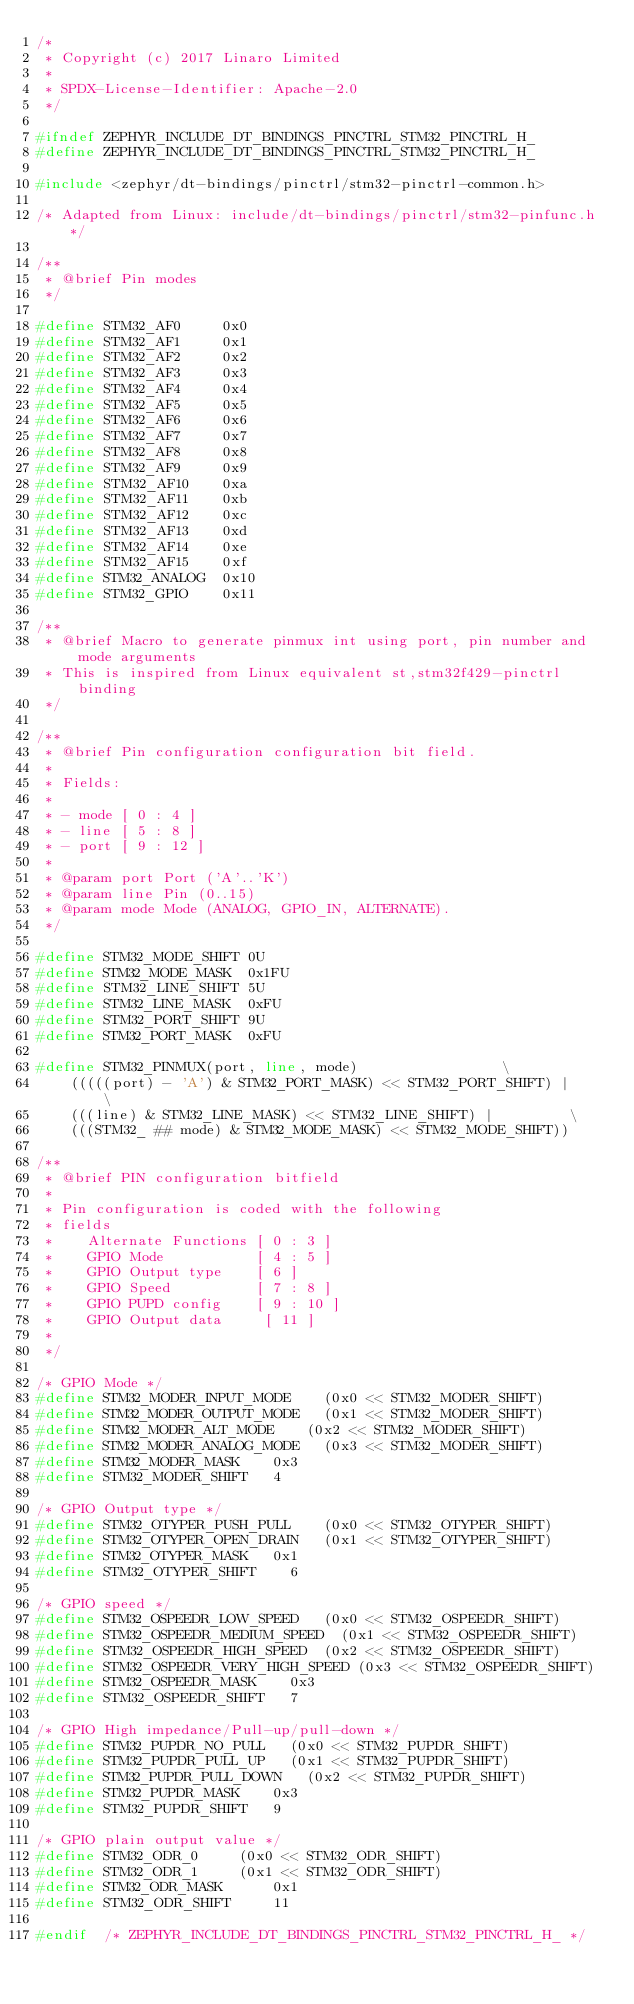<code> <loc_0><loc_0><loc_500><loc_500><_C_>/*
 * Copyright (c) 2017 Linaro Limited
 *
 * SPDX-License-Identifier: Apache-2.0
 */

#ifndef ZEPHYR_INCLUDE_DT_BINDINGS_PINCTRL_STM32_PINCTRL_H_
#define ZEPHYR_INCLUDE_DT_BINDINGS_PINCTRL_STM32_PINCTRL_H_

#include <zephyr/dt-bindings/pinctrl/stm32-pinctrl-common.h>

/* Adapted from Linux: include/dt-bindings/pinctrl/stm32-pinfunc.h */

/**
 * @brief Pin modes
 */

#define STM32_AF0     0x0
#define STM32_AF1     0x1
#define STM32_AF2     0x2
#define STM32_AF3     0x3
#define STM32_AF4     0x4
#define STM32_AF5     0x5
#define STM32_AF6     0x6
#define STM32_AF7     0x7
#define STM32_AF8     0x8
#define STM32_AF9     0x9
#define STM32_AF10    0xa
#define STM32_AF11    0xb
#define STM32_AF12    0xc
#define STM32_AF13    0xd
#define STM32_AF14    0xe
#define STM32_AF15    0xf
#define STM32_ANALOG  0x10
#define STM32_GPIO    0x11

/**
 * @brief Macro to generate pinmux int using port, pin number and mode arguments
 * This is inspired from Linux equivalent st,stm32f429-pinctrl binding
 */

/**
 * @brief Pin configuration configuration bit field.
 *
 * Fields:
 *
 * - mode [ 0 : 4 ]
 * - line [ 5 : 8 ]
 * - port [ 9 : 12 ]
 *
 * @param port Port ('A'..'K')
 * @param line Pin (0..15)
 * @param mode Mode (ANALOG, GPIO_IN, ALTERNATE).
 */

#define STM32_MODE_SHIFT 0U
#define STM32_MODE_MASK  0x1FU
#define STM32_LINE_SHIFT 5U
#define STM32_LINE_MASK  0xFU
#define STM32_PORT_SHIFT 9U
#define STM32_PORT_MASK  0xFU

#define STM32_PINMUX(port, line, mode)					       \
		(((((port) - 'A') & STM32_PORT_MASK) << STM32_PORT_SHIFT) |    \
		(((line) & STM32_LINE_MASK) << STM32_LINE_SHIFT) |	       \
		(((STM32_ ## mode) & STM32_MODE_MASK) << STM32_MODE_SHIFT))

/**
 * @brief PIN configuration bitfield
 *
 * Pin configuration is coded with the following
 * fields
 *    Alternate Functions [ 0 : 3 ]
 *    GPIO Mode           [ 4 : 5 ]
 *    GPIO Output type    [ 6 ]
 *    GPIO Speed          [ 7 : 8 ]
 *    GPIO PUPD config    [ 9 : 10 ]
 *    GPIO Output data     [ 11 ]
 *
 */

/* GPIO Mode */
#define STM32_MODER_INPUT_MODE		(0x0 << STM32_MODER_SHIFT)
#define STM32_MODER_OUTPUT_MODE		(0x1 << STM32_MODER_SHIFT)
#define STM32_MODER_ALT_MODE		(0x2 << STM32_MODER_SHIFT)
#define STM32_MODER_ANALOG_MODE		(0x3 << STM32_MODER_SHIFT)
#define STM32_MODER_MASK	 	0x3
#define STM32_MODER_SHIFT		4

/* GPIO Output type */
#define STM32_OTYPER_PUSH_PULL		(0x0 << STM32_OTYPER_SHIFT)
#define STM32_OTYPER_OPEN_DRAIN		(0x1 << STM32_OTYPER_SHIFT)
#define STM32_OTYPER_MASK		0x1
#define STM32_OTYPER_SHIFT		6

/* GPIO speed */
#define STM32_OSPEEDR_LOW_SPEED		(0x0 << STM32_OSPEEDR_SHIFT)
#define STM32_OSPEEDR_MEDIUM_SPEED	(0x1 << STM32_OSPEEDR_SHIFT)
#define STM32_OSPEEDR_HIGH_SPEED	(0x2 << STM32_OSPEEDR_SHIFT)
#define STM32_OSPEEDR_VERY_HIGH_SPEED	(0x3 << STM32_OSPEEDR_SHIFT)
#define STM32_OSPEEDR_MASK		0x3
#define STM32_OSPEEDR_SHIFT		7

/* GPIO High impedance/Pull-up/pull-down */
#define STM32_PUPDR_NO_PULL		(0x0 << STM32_PUPDR_SHIFT)
#define STM32_PUPDR_PULL_UP		(0x1 << STM32_PUPDR_SHIFT)
#define STM32_PUPDR_PULL_DOWN		(0x2 << STM32_PUPDR_SHIFT)
#define STM32_PUPDR_MASK		0x3
#define STM32_PUPDR_SHIFT		9

/* GPIO plain output value */
#define STM32_ODR_0			(0x0 << STM32_ODR_SHIFT)
#define STM32_ODR_1			(0x1 << STM32_ODR_SHIFT)
#define STM32_ODR_MASK			0x1
#define STM32_ODR_SHIFT			11

#endif	/* ZEPHYR_INCLUDE_DT_BINDINGS_PINCTRL_STM32_PINCTRL_H_ */
</code> 